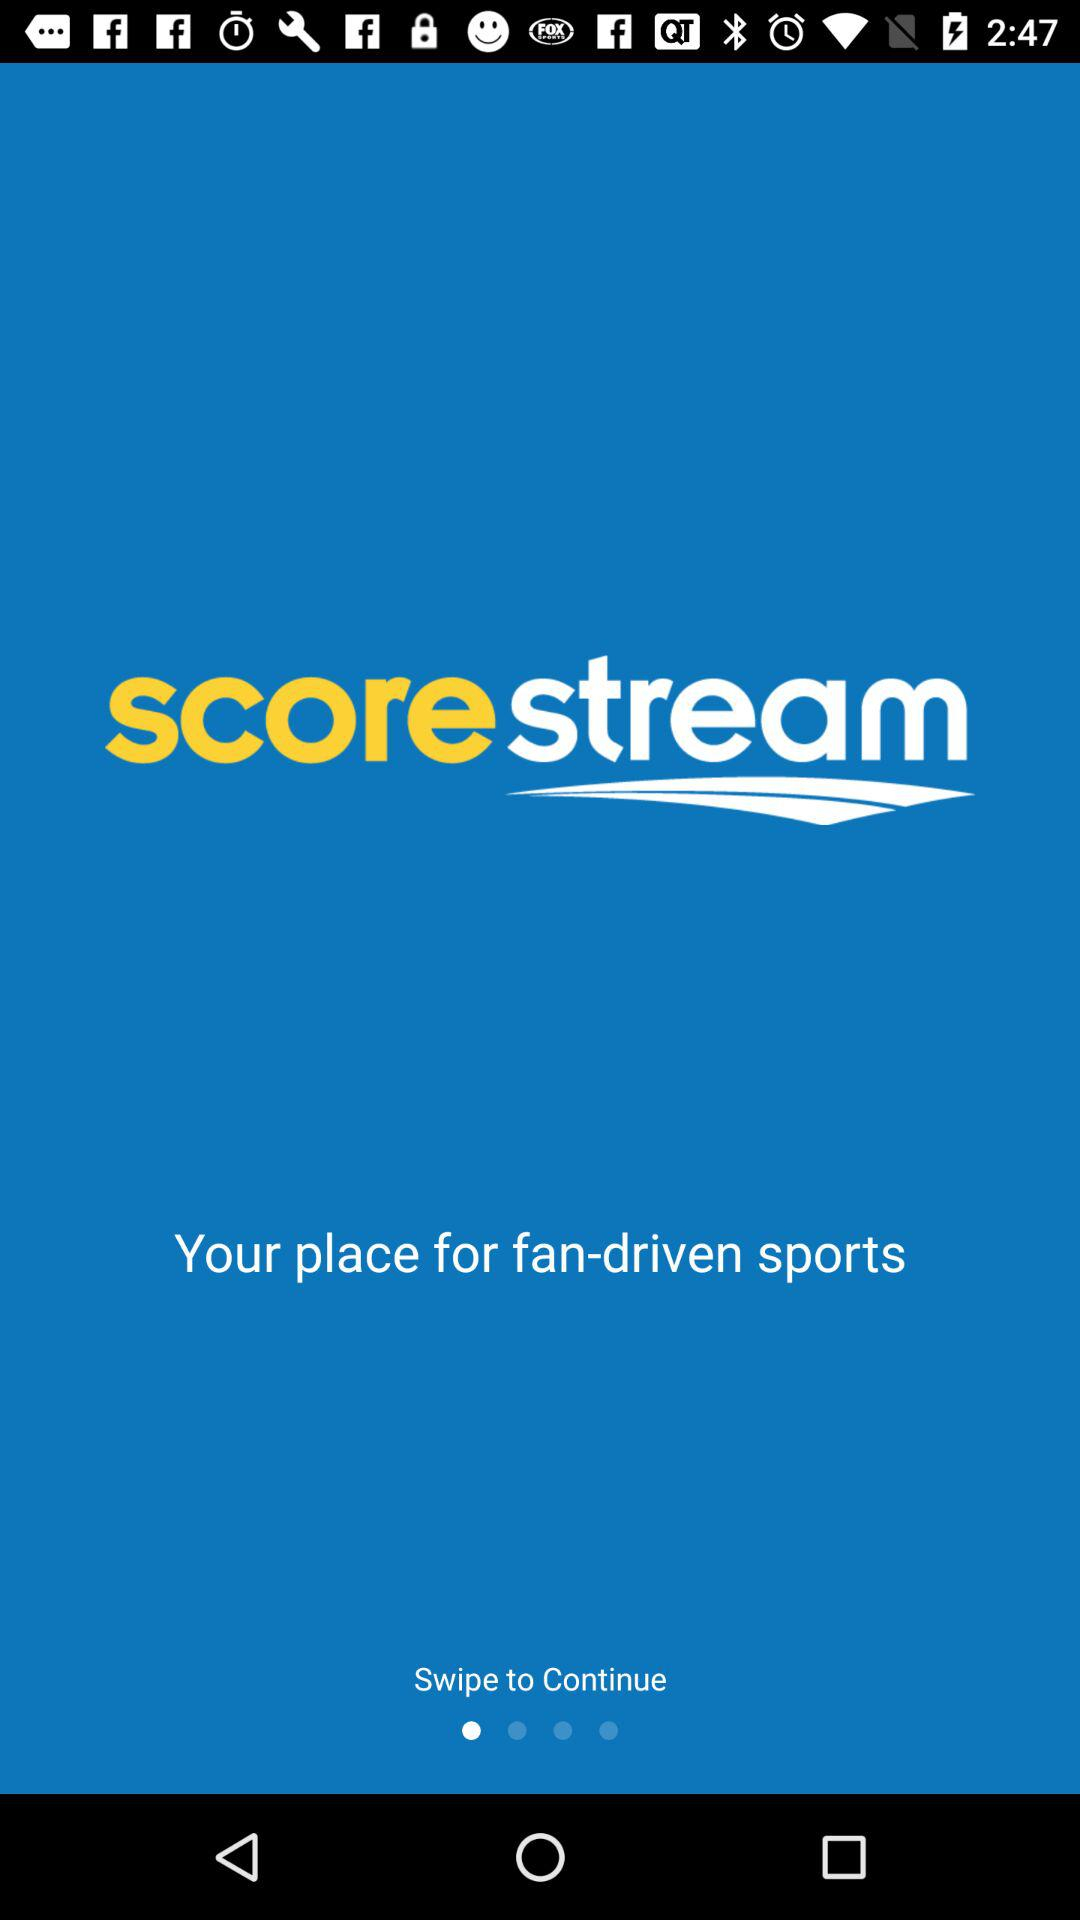What is the name of the application? The name of the application is "scorestream". 